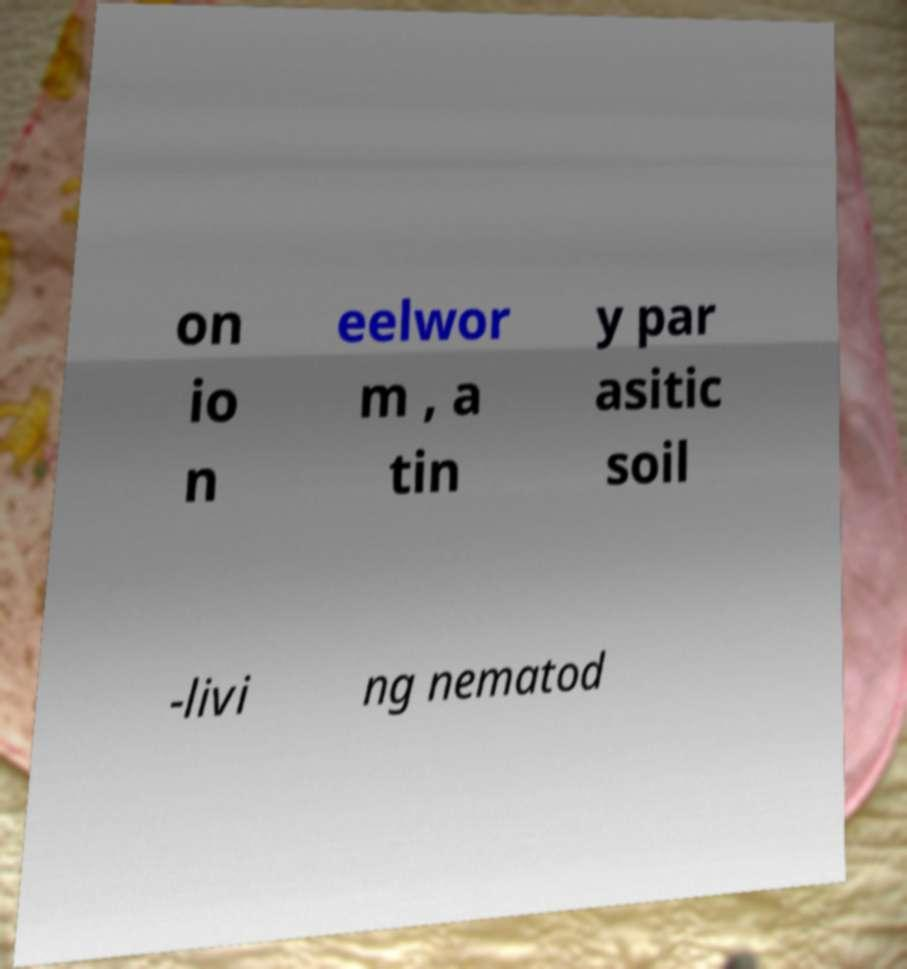There's text embedded in this image that I need extracted. Can you transcribe it verbatim? on io n eelwor m , a tin y par asitic soil -livi ng nematod 